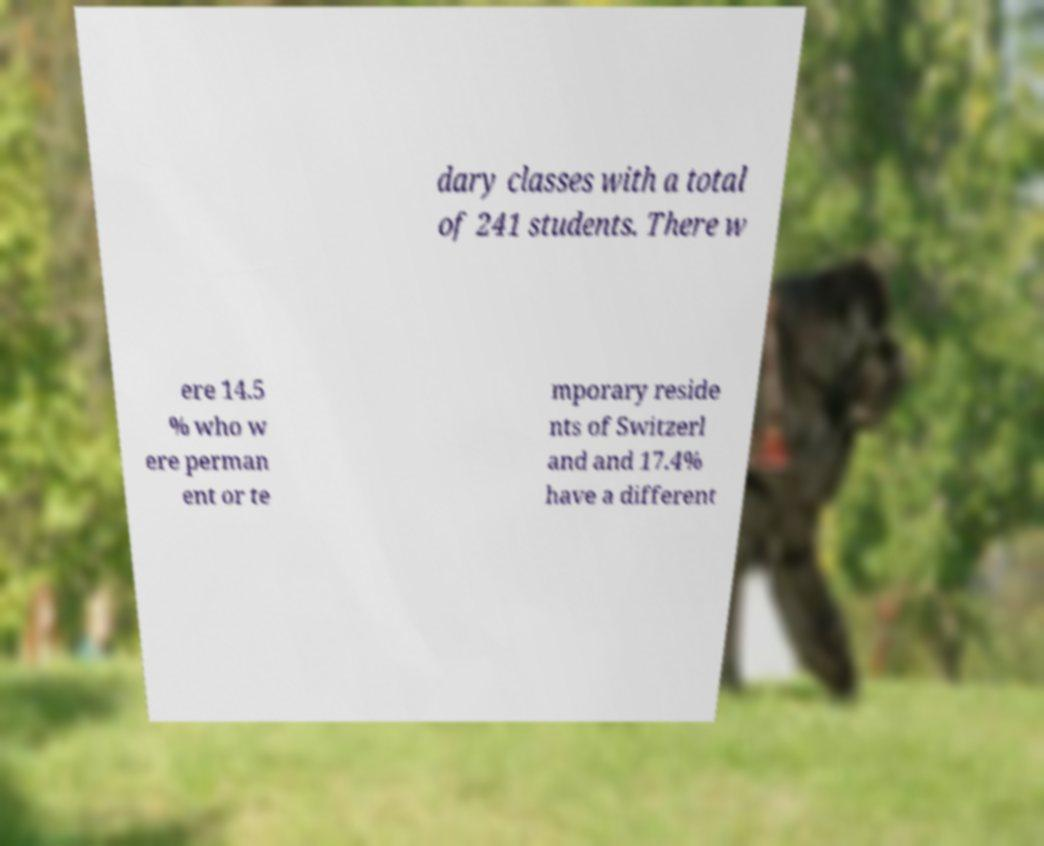There's text embedded in this image that I need extracted. Can you transcribe it verbatim? dary classes with a total of 241 students. There w ere 14.5 % who w ere perman ent or te mporary reside nts of Switzerl and and 17.4% have a different 